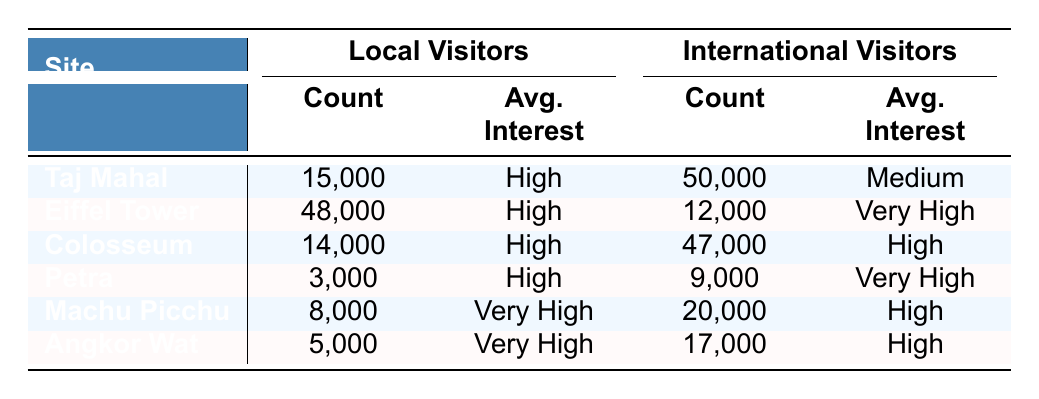What is the attendance count for local visitors at the Taj Mahal? The table shows the attendance count for local visitors at the Taj Mahal as 15,000.
Answer: 15,000 What is the average visitor interest level for international visitors at the Eiffel Tower? The average interest level for international visitors at the Eiffel Tower is listed as Very High.
Answer: Very High Which site has the highest total attendance from both local and international visitors? By summing the attendance counts: Taj Mahal (15,000 + 50,000 = 65,000), Eiffel Tower (48,000 + 12,000 = 60,000), Colosseum (14,000 + 47,000 = 61,000), Petra (3,000 + 9,000 = 12,000), Machu Picchu (8,000 + 20,000 = 28,000), and Angkor Wat (5,000 + 17,000 = 22,000), the Taj Mahal has the highest total count of 65,000.
Answer: Taj Mahal Are there more local or international visitors at Machu Picchu? The table shows that there are 8,000 local visitors and 20,000 international visitors at Machu Picchu, indicating there are more international visitors.
Answer: International visitors What is the total attendance count for local visitors across all sites? Adding the local visitor counts from each site: Taj Mahal (15,000) + Eiffel Tower (48,000) + Colosseum (14,000) + Petra (3,000) + Machu Picchu (8,000) + Angkor Wat (5,000) gives a total of 93,000 local visitors.
Answer: 93,000 What percentage of local visitors at the Colosseum have a high preservation interest? The table indicates that all 14,000 local visitors at the Colosseum have a high preservation interest, which means the percentage is 100%.
Answer: 100% Which site has the lowest attendance from local visitors? The table shows that Petra has the lowest attendance from local visitors with a count of 3,000.
Answer: Petra Is the average interest level for local visitors at the Taj Mahal higher than for international visitors? The average interest for local visitors at the Taj Mahal is High, while for international visitors it is Medium, indicating that local visitors have a higher average interest level.
Answer: Yes What is the difference in attendance counts between local and international visitors at Angkor Wat? The attendance count for local visitors at Angkor Wat is 5,000, while for international visitors it is 17,000. The difference is calculated as 17,000 - 5,000 = 12,000.
Answer: 12,000 What is the total attendance for 41-60 age group visitors across all sites? The count for the 41-60 age group is from the Eiffel Tower (18,000), Petra (9,000), and Angkor Wat (17,000), summing to 44,000 total attendance.
Answer: 44,000 